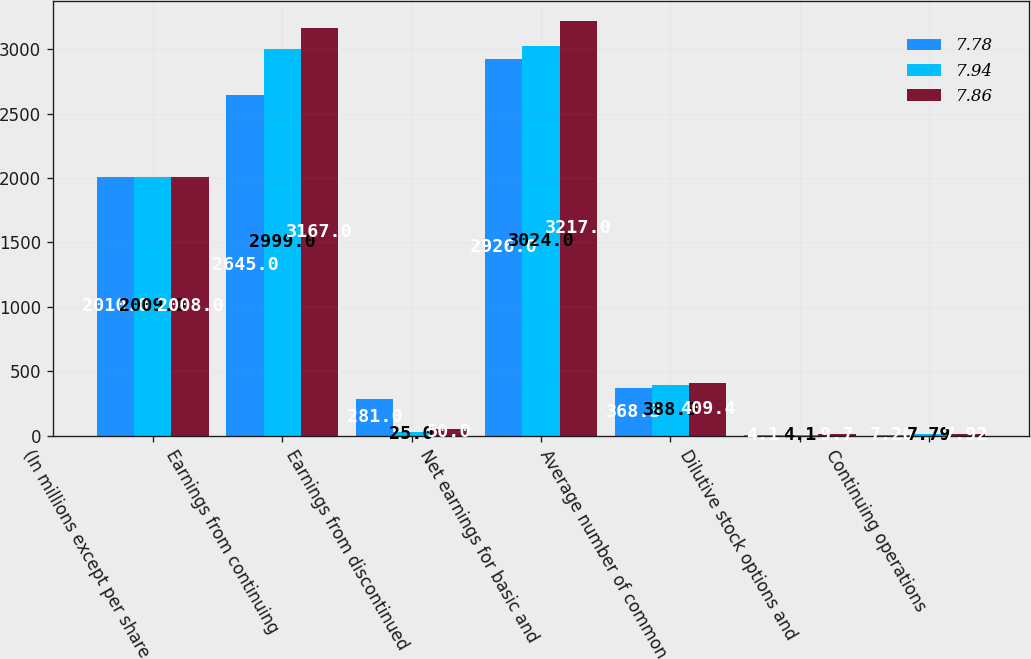Convert chart to OTSL. <chart><loc_0><loc_0><loc_500><loc_500><stacked_bar_chart><ecel><fcel>(In millions except per share<fcel>Earnings from continuing<fcel>Earnings from discontinued<fcel>Net earnings for basic and<fcel>Average number of common<fcel>Dilutive stock options and<fcel>Continuing operations<nl><fcel>7.78<fcel>2010<fcel>2645<fcel>281<fcel>2926<fcel>368.3<fcel>4.1<fcel>7.26<nl><fcel>7.94<fcel>2009<fcel>2999<fcel>25<fcel>3024<fcel>388.9<fcel>4.1<fcel>7.79<nl><fcel>7.86<fcel>2008<fcel>3167<fcel>50<fcel>3217<fcel>409.4<fcel>9.7<fcel>7.92<nl></chart> 